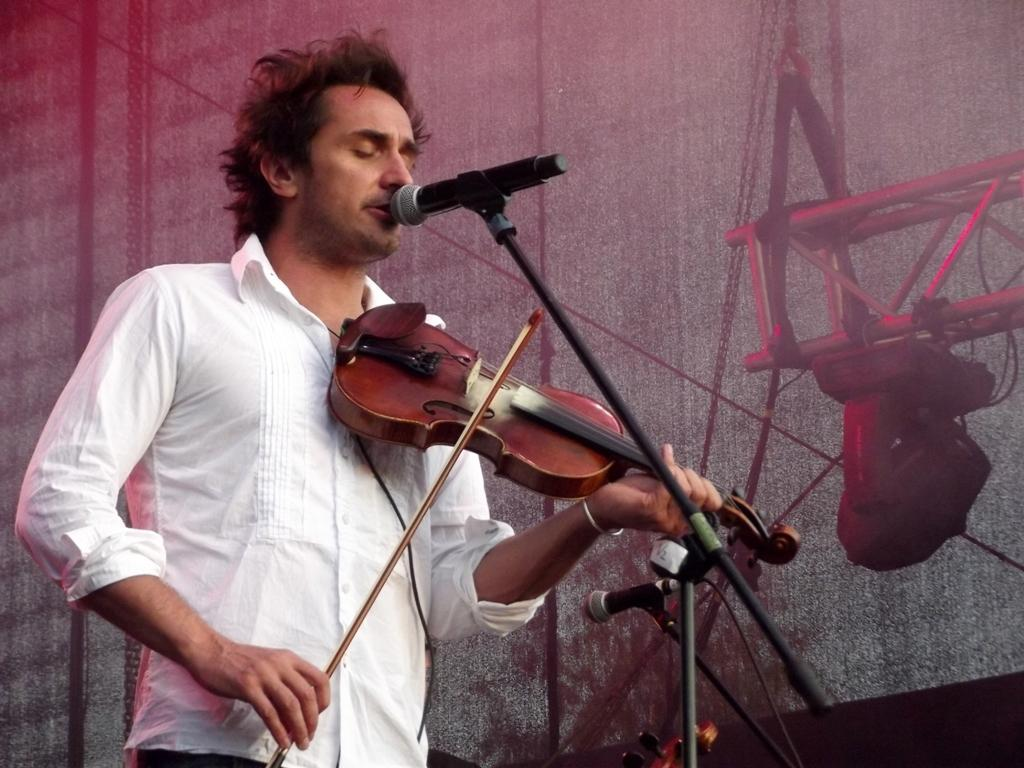What is the man in the image doing? The man is playing a musical instrument. What object is present in the image that might be used for amplifying sound? There is a microphone in the image. What type of relation does the man have with the quiver in the image? There is no quiver present in the image, so the man does not have any relation to it. 